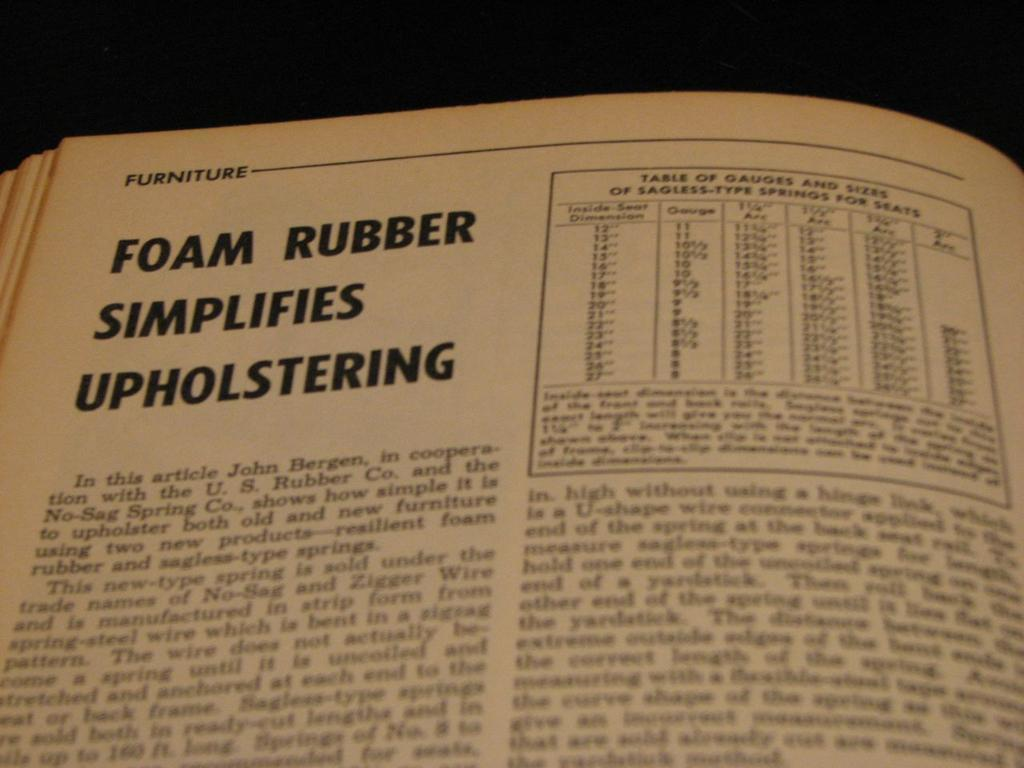<image>
Create a compact narrative representing the image presented. Page from a book which says "Foam rubber Simplifies Upholstering". 